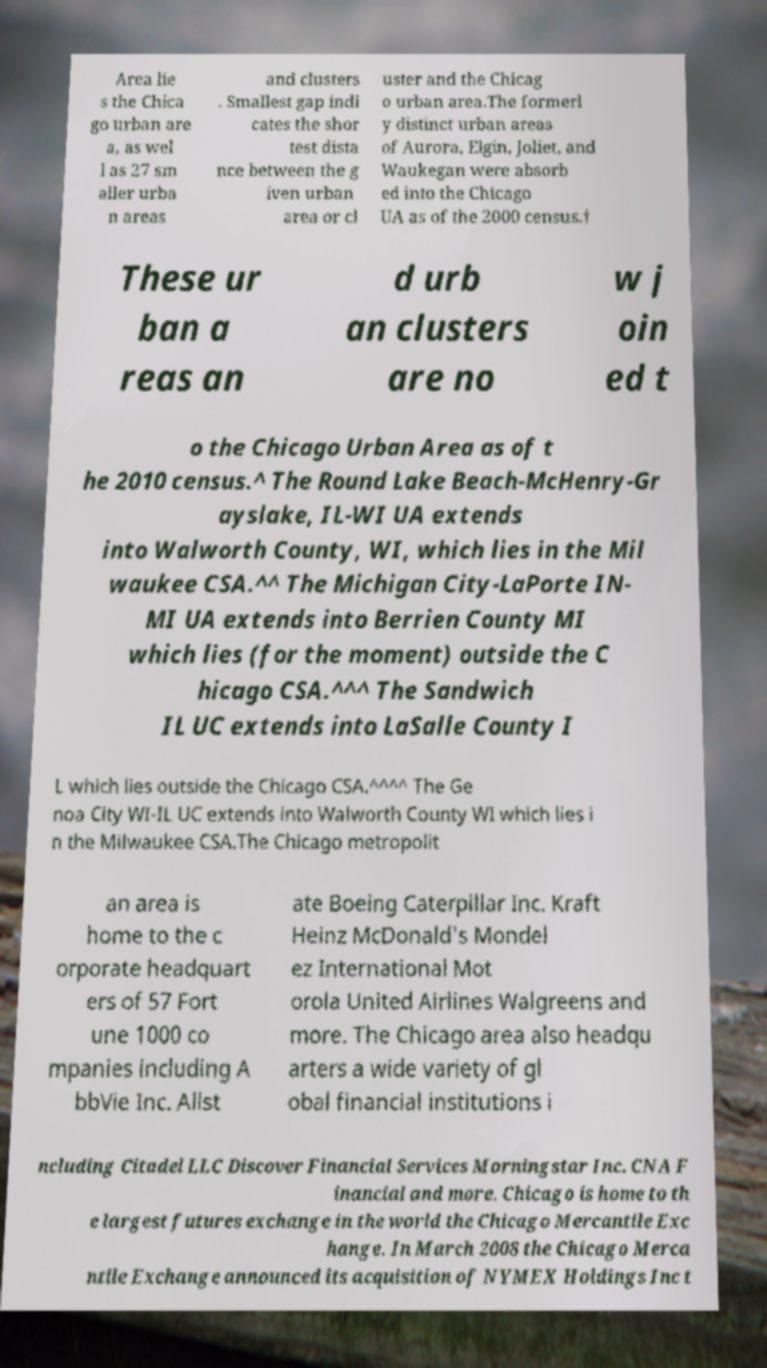For documentation purposes, I need the text within this image transcribed. Could you provide that? Area lie s the Chica go urban are a, as wel l as 27 sm aller urba n areas and clusters . Smallest gap indi cates the shor test dista nce between the g iven urban area or cl uster and the Chicag o urban area.The formerl y distinct urban areas of Aurora, Elgin, Joliet, and Waukegan were absorb ed into the Chicago UA as of the 2000 census.† These ur ban a reas an d urb an clusters are no w j oin ed t o the Chicago Urban Area as of t he 2010 census.^ The Round Lake Beach-McHenry-Gr ayslake, IL-WI UA extends into Walworth County, WI, which lies in the Mil waukee CSA.^^ The Michigan City-LaPorte IN- MI UA extends into Berrien County MI which lies (for the moment) outside the C hicago CSA.^^^ The Sandwich IL UC extends into LaSalle County I L which lies outside the Chicago CSA.^^^^ The Ge noa City WI-IL UC extends into Walworth County WI which lies i n the Milwaukee CSA.The Chicago metropolit an area is home to the c orporate headquart ers of 57 Fort une 1000 co mpanies including A bbVie Inc. Allst ate Boeing Caterpillar Inc. Kraft Heinz McDonald's Mondel ez International Mot orola United Airlines Walgreens and more. The Chicago area also headqu arters a wide variety of gl obal financial institutions i ncluding Citadel LLC Discover Financial Services Morningstar Inc. CNA F inancial and more. Chicago is home to th e largest futures exchange in the world the Chicago Mercantile Exc hange. In March 2008 the Chicago Merca ntile Exchange announced its acquisition of NYMEX Holdings Inc t 